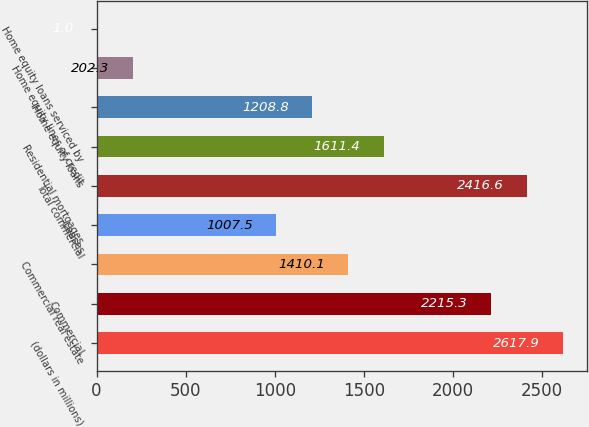<chart> <loc_0><loc_0><loc_500><loc_500><bar_chart><fcel>(dollars in millions)<fcel>Commercial<fcel>Commercial real estate<fcel>Leases<fcel>Total commercial<fcel>Residential mortgages<fcel>Home equity loans<fcel>Home equity lines of credit<fcel>Home equity loans serviced by<nl><fcel>2617.9<fcel>2215.3<fcel>1410.1<fcel>1007.5<fcel>2416.6<fcel>1611.4<fcel>1208.8<fcel>202.3<fcel>1<nl></chart> 